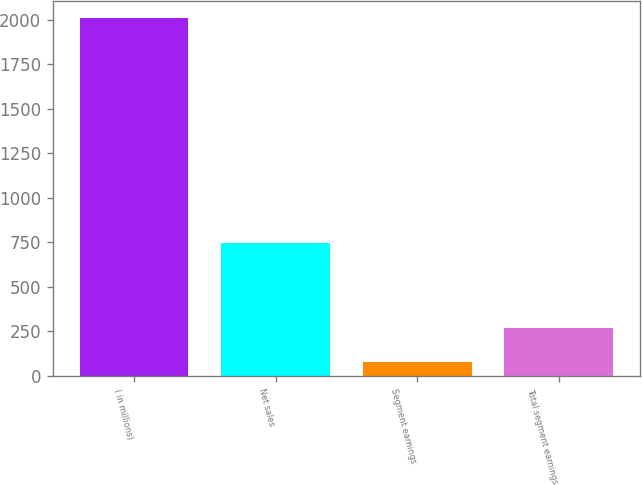Convert chart to OTSL. <chart><loc_0><loc_0><loc_500><loc_500><bar_chart><fcel>( in millions)<fcel>Net sales<fcel>Segment earnings<fcel>Total segment earnings<nl><fcel>2008<fcel>746.5<fcel>76.2<fcel>269.38<nl></chart> 